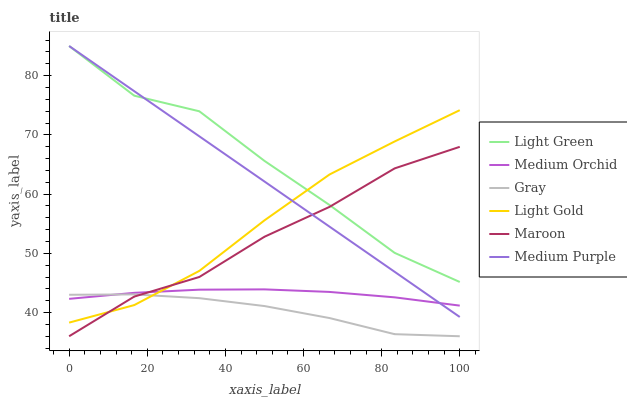Does Gray have the minimum area under the curve?
Answer yes or no. Yes. Does Light Green have the maximum area under the curve?
Answer yes or no. Yes. Does Medium Orchid have the minimum area under the curve?
Answer yes or no. No. Does Medium Orchid have the maximum area under the curve?
Answer yes or no. No. Is Medium Purple the smoothest?
Answer yes or no. Yes. Is Light Green the roughest?
Answer yes or no. Yes. Is Medium Orchid the smoothest?
Answer yes or no. No. Is Medium Orchid the roughest?
Answer yes or no. No. Does Gray have the lowest value?
Answer yes or no. Yes. Does Medium Orchid have the lowest value?
Answer yes or no. No. Does Light Green have the highest value?
Answer yes or no. Yes. Does Medium Orchid have the highest value?
Answer yes or no. No. Is Gray less than Medium Purple?
Answer yes or no. Yes. Is Medium Purple greater than Gray?
Answer yes or no. Yes. Does Light Gold intersect Light Green?
Answer yes or no. Yes. Is Light Gold less than Light Green?
Answer yes or no. No. Is Light Gold greater than Light Green?
Answer yes or no. No. Does Gray intersect Medium Purple?
Answer yes or no. No. 